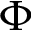Convert formula to latex. <formula><loc_0><loc_0><loc_500><loc_500>\Phi</formula> 